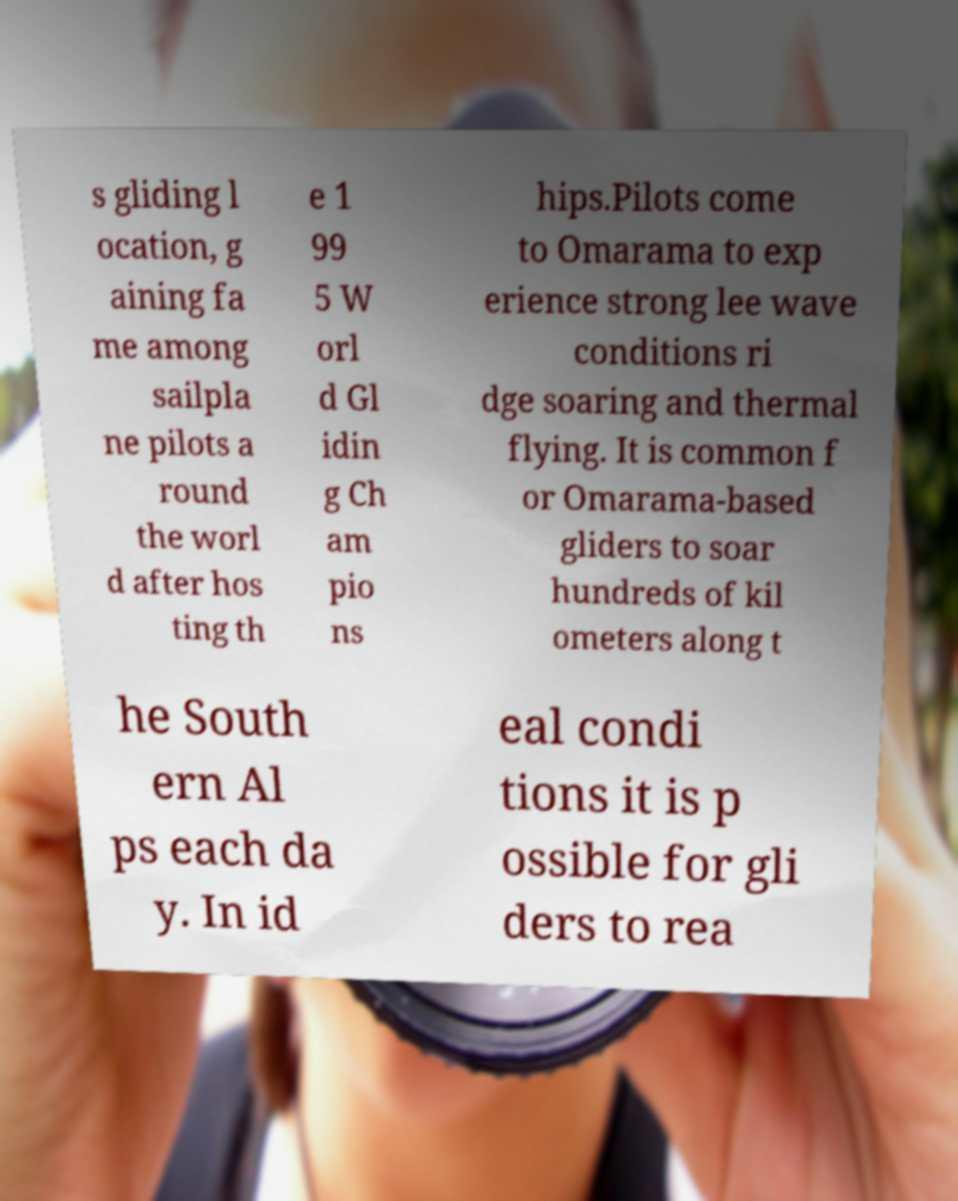Can you accurately transcribe the text from the provided image for me? s gliding l ocation, g aining fa me among sailpla ne pilots a round the worl d after hos ting th e 1 99 5 W orl d Gl idin g Ch am pio ns hips.Pilots come to Omarama to exp erience strong lee wave conditions ri dge soaring and thermal flying. It is common f or Omarama-based gliders to soar hundreds of kil ometers along t he South ern Al ps each da y. In id eal condi tions it is p ossible for gli ders to rea 